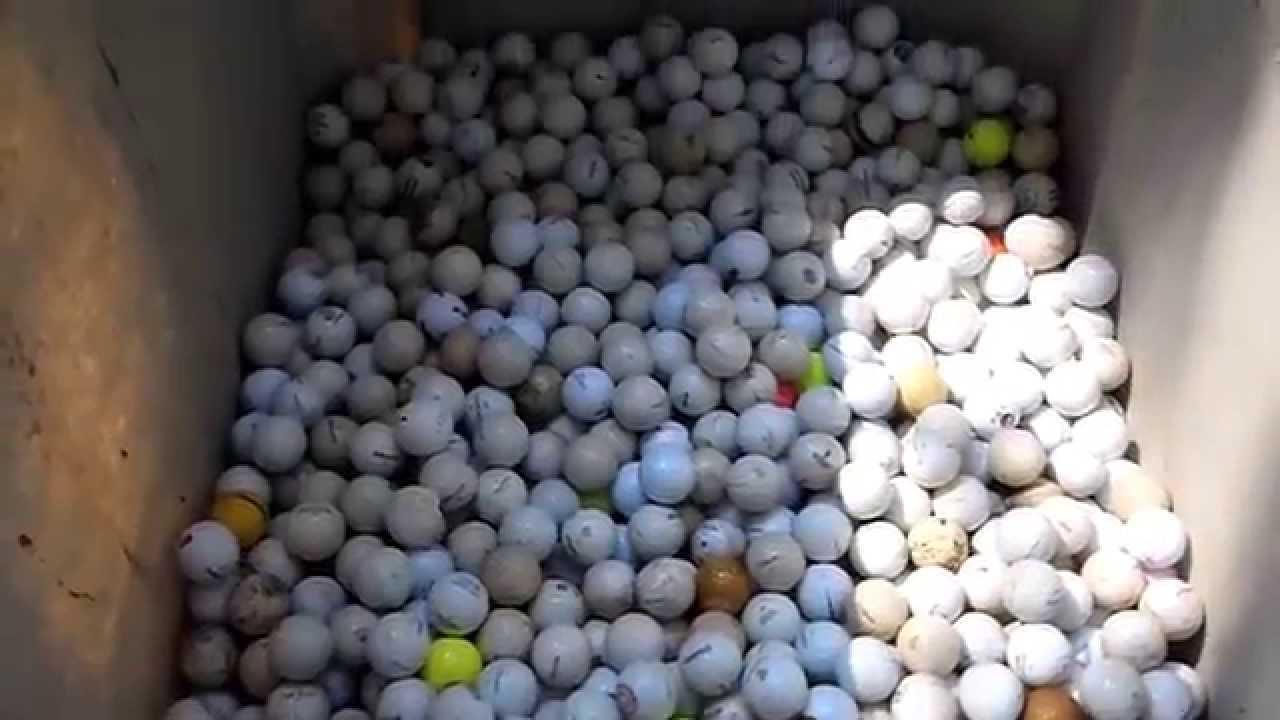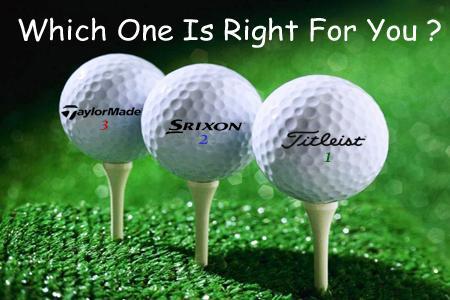The first image is the image on the left, the second image is the image on the right. For the images displayed, is the sentence "An image shows an angled row of three white golf balls on tees on green carpet." factually correct? Answer yes or no. Yes. The first image is the image on the left, the second image is the image on the right. For the images displayed, is the sentence "Three balls are on tees in one of the images." factually correct? Answer yes or no. Yes. 